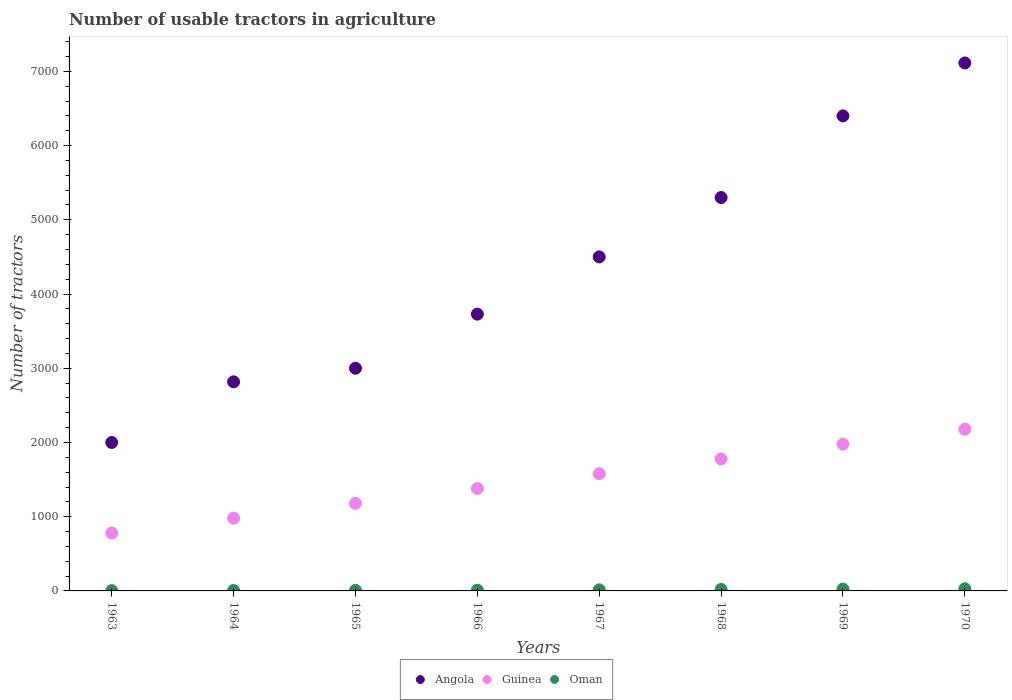How many different coloured dotlines are there?
Give a very brief answer. 3. Across all years, what is the maximum number of usable tractors in agriculture in Guinea?
Offer a very short reply. 2178. In which year was the number of usable tractors in agriculture in Angola minimum?
Offer a very short reply. 1963. What is the total number of usable tractors in agriculture in Oman in the graph?
Provide a short and direct response. 118. What is the difference between the number of usable tractors in agriculture in Angola in 1965 and that in 1969?
Make the answer very short. -3400. What is the difference between the number of usable tractors in agriculture in Angola in 1968 and the number of usable tractors in agriculture in Oman in 1963?
Offer a terse response. 5296. What is the average number of usable tractors in agriculture in Angola per year?
Provide a short and direct response. 4357.38. In the year 1967, what is the difference between the number of usable tractors in agriculture in Oman and number of usable tractors in agriculture in Guinea?
Your answer should be compact. -1564. What is the ratio of the number of usable tractors in agriculture in Angola in 1964 to that in 1969?
Give a very brief answer. 0.44. Is the number of usable tractors in agriculture in Oman in 1963 less than that in 1970?
Provide a short and direct response. Yes. What is the difference between the highest and the lowest number of usable tractors in agriculture in Angola?
Provide a succinct answer. 5113. In how many years, is the number of usable tractors in agriculture in Guinea greater than the average number of usable tractors in agriculture in Guinea taken over all years?
Offer a very short reply. 4. Is the sum of the number of usable tractors in agriculture in Guinea in 1964 and 1965 greater than the maximum number of usable tractors in agriculture in Oman across all years?
Your answer should be compact. Yes. Does the number of usable tractors in agriculture in Angola monotonically increase over the years?
Keep it short and to the point. Yes. Is the number of usable tractors in agriculture in Angola strictly greater than the number of usable tractors in agriculture in Oman over the years?
Ensure brevity in your answer.  Yes. Is the number of usable tractors in agriculture in Guinea strictly less than the number of usable tractors in agriculture in Angola over the years?
Your response must be concise. Yes. How many years are there in the graph?
Your answer should be very brief. 8. What is the difference between two consecutive major ticks on the Y-axis?
Your answer should be very brief. 1000. Does the graph contain any zero values?
Your answer should be very brief. No. Where does the legend appear in the graph?
Your answer should be very brief. Bottom center. How are the legend labels stacked?
Keep it short and to the point. Horizontal. What is the title of the graph?
Make the answer very short. Number of usable tractors in agriculture. What is the label or title of the Y-axis?
Ensure brevity in your answer.  Number of tractors. What is the Number of tractors of Angola in 1963?
Your answer should be compact. 2000. What is the Number of tractors of Guinea in 1963?
Make the answer very short. 780. What is the Number of tractors in Angola in 1964?
Your answer should be compact. 2817. What is the Number of tractors of Guinea in 1964?
Make the answer very short. 980. What is the Number of tractors in Angola in 1965?
Provide a short and direct response. 3000. What is the Number of tractors in Guinea in 1965?
Your answer should be very brief. 1180. What is the Number of tractors in Angola in 1966?
Your response must be concise. 3729. What is the Number of tractors of Guinea in 1966?
Your response must be concise. 1379. What is the Number of tractors of Angola in 1967?
Make the answer very short. 4500. What is the Number of tractors of Guinea in 1967?
Your answer should be very brief. 1579. What is the Number of tractors in Angola in 1968?
Your answer should be very brief. 5300. What is the Number of tractors in Guinea in 1968?
Offer a very short reply. 1778. What is the Number of tractors in Angola in 1969?
Make the answer very short. 6400. What is the Number of tractors of Guinea in 1969?
Give a very brief answer. 1978. What is the Number of tractors in Oman in 1969?
Offer a very short reply. 25. What is the Number of tractors of Angola in 1970?
Keep it short and to the point. 7113. What is the Number of tractors of Guinea in 1970?
Keep it short and to the point. 2178. Across all years, what is the maximum Number of tractors in Angola?
Provide a short and direct response. 7113. Across all years, what is the maximum Number of tractors in Guinea?
Offer a terse response. 2178. Across all years, what is the maximum Number of tractors of Oman?
Keep it short and to the point. 30. Across all years, what is the minimum Number of tractors in Angola?
Provide a short and direct response. 2000. Across all years, what is the minimum Number of tractors in Guinea?
Your answer should be very brief. 780. Across all years, what is the minimum Number of tractors of Oman?
Ensure brevity in your answer.  4. What is the total Number of tractors in Angola in the graph?
Make the answer very short. 3.49e+04. What is the total Number of tractors in Guinea in the graph?
Your response must be concise. 1.18e+04. What is the total Number of tractors in Oman in the graph?
Make the answer very short. 118. What is the difference between the Number of tractors in Angola in 1963 and that in 1964?
Make the answer very short. -817. What is the difference between the Number of tractors of Guinea in 1963 and that in 1964?
Ensure brevity in your answer.  -200. What is the difference between the Number of tractors of Oman in 1963 and that in 1964?
Provide a succinct answer. -2. What is the difference between the Number of tractors in Angola in 1963 and that in 1965?
Keep it short and to the point. -1000. What is the difference between the Number of tractors in Guinea in 1963 and that in 1965?
Your answer should be very brief. -400. What is the difference between the Number of tractors of Oman in 1963 and that in 1965?
Offer a terse response. -4. What is the difference between the Number of tractors in Angola in 1963 and that in 1966?
Your answer should be very brief. -1729. What is the difference between the Number of tractors of Guinea in 1963 and that in 1966?
Make the answer very short. -599. What is the difference between the Number of tractors in Angola in 1963 and that in 1967?
Provide a short and direct response. -2500. What is the difference between the Number of tractors in Guinea in 1963 and that in 1967?
Offer a very short reply. -799. What is the difference between the Number of tractors in Oman in 1963 and that in 1967?
Provide a short and direct response. -11. What is the difference between the Number of tractors of Angola in 1963 and that in 1968?
Your response must be concise. -3300. What is the difference between the Number of tractors of Guinea in 1963 and that in 1968?
Your answer should be very brief. -998. What is the difference between the Number of tractors in Angola in 1963 and that in 1969?
Ensure brevity in your answer.  -4400. What is the difference between the Number of tractors in Guinea in 1963 and that in 1969?
Make the answer very short. -1198. What is the difference between the Number of tractors of Angola in 1963 and that in 1970?
Give a very brief answer. -5113. What is the difference between the Number of tractors in Guinea in 1963 and that in 1970?
Provide a short and direct response. -1398. What is the difference between the Number of tractors in Angola in 1964 and that in 1965?
Your answer should be compact. -183. What is the difference between the Number of tractors in Guinea in 1964 and that in 1965?
Keep it short and to the point. -200. What is the difference between the Number of tractors in Oman in 1964 and that in 1965?
Ensure brevity in your answer.  -2. What is the difference between the Number of tractors of Angola in 1964 and that in 1966?
Provide a short and direct response. -912. What is the difference between the Number of tractors in Guinea in 1964 and that in 1966?
Your answer should be very brief. -399. What is the difference between the Number of tractors of Oman in 1964 and that in 1966?
Your answer should be compact. -4. What is the difference between the Number of tractors in Angola in 1964 and that in 1967?
Your answer should be very brief. -1683. What is the difference between the Number of tractors of Guinea in 1964 and that in 1967?
Keep it short and to the point. -599. What is the difference between the Number of tractors of Angola in 1964 and that in 1968?
Offer a terse response. -2483. What is the difference between the Number of tractors of Guinea in 1964 and that in 1968?
Your response must be concise. -798. What is the difference between the Number of tractors of Angola in 1964 and that in 1969?
Your answer should be very brief. -3583. What is the difference between the Number of tractors of Guinea in 1964 and that in 1969?
Your answer should be very brief. -998. What is the difference between the Number of tractors of Oman in 1964 and that in 1969?
Give a very brief answer. -19. What is the difference between the Number of tractors of Angola in 1964 and that in 1970?
Keep it short and to the point. -4296. What is the difference between the Number of tractors in Guinea in 1964 and that in 1970?
Your answer should be very brief. -1198. What is the difference between the Number of tractors in Oman in 1964 and that in 1970?
Keep it short and to the point. -24. What is the difference between the Number of tractors in Angola in 1965 and that in 1966?
Offer a terse response. -729. What is the difference between the Number of tractors of Guinea in 1965 and that in 1966?
Provide a short and direct response. -199. What is the difference between the Number of tractors of Oman in 1965 and that in 1966?
Ensure brevity in your answer.  -2. What is the difference between the Number of tractors in Angola in 1965 and that in 1967?
Provide a short and direct response. -1500. What is the difference between the Number of tractors in Guinea in 1965 and that in 1967?
Provide a short and direct response. -399. What is the difference between the Number of tractors in Angola in 1965 and that in 1968?
Provide a short and direct response. -2300. What is the difference between the Number of tractors in Guinea in 1965 and that in 1968?
Your answer should be very brief. -598. What is the difference between the Number of tractors in Angola in 1965 and that in 1969?
Keep it short and to the point. -3400. What is the difference between the Number of tractors of Guinea in 1965 and that in 1969?
Ensure brevity in your answer.  -798. What is the difference between the Number of tractors in Oman in 1965 and that in 1969?
Give a very brief answer. -17. What is the difference between the Number of tractors in Angola in 1965 and that in 1970?
Provide a short and direct response. -4113. What is the difference between the Number of tractors in Guinea in 1965 and that in 1970?
Give a very brief answer. -998. What is the difference between the Number of tractors in Oman in 1965 and that in 1970?
Ensure brevity in your answer.  -22. What is the difference between the Number of tractors of Angola in 1966 and that in 1967?
Provide a short and direct response. -771. What is the difference between the Number of tractors of Guinea in 1966 and that in 1967?
Your answer should be very brief. -200. What is the difference between the Number of tractors of Angola in 1966 and that in 1968?
Offer a terse response. -1571. What is the difference between the Number of tractors in Guinea in 1966 and that in 1968?
Ensure brevity in your answer.  -399. What is the difference between the Number of tractors of Oman in 1966 and that in 1968?
Your response must be concise. -10. What is the difference between the Number of tractors in Angola in 1966 and that in 1969?
Keep it short and to the point. -2671. What is the difference between the Number of tractors in Guinea in 1966 and that in 1969?
Your answer should be very brief. -599. What is the difference between the Number of tractors in Angola in 1966 and that in 1970?
Provide a short and direct response. -3384. What is the difference between the Number of tractors in Guinea in 1966 and that in 1970?
Provide a short and direct response. -799. What is the difference between the Number of tractors of Angola in 1967 and that in 1968?
Give a very brief answer. -800. What is the difference between the Number of tractors of Guinea in 1967 and that in 1968?
Your response must be concise. -199. What is the difference between the Number of tractors of Angola in 1967 and that in 1969?
Keep it short and to the point. -1900. What is the difference between the Number of tractors in Guinea in 1967 and that in 1969?
Give a very brief answer. -399. What is the difference between the Number of tractors of Oman in 1967 and that in 1969?
Your answer should be compact. -10. What is the difference between the Number of tractors of Angola in 1967 and that in 1970?
Make the answer very short. -2613. What is the difference between the Number of tractors in Guinea in 1967 and that in 1970?
Provide a succinct answer. -599. What is the difference between the Number of tractors of Oman in 1967 and that in 1970?
Provide a short and direct response. -15. What is the difference between the Number of tractors of Angola in 1968 and that in 1969?
Your response must be concise. -1100. What is the difference between the Number of tractors of Guinea in 1968 and that in 1969?
Offer a very short reply. -200. What is the difference between the Number of tractors in Angola in 1968 and that in 1970?
Keep it short and to the point. -1813. What is the difference between the Number of tractors in Guinea in 1968 and that in 1970?
Make the answer very short. -400. What is the difference between the Number of tractors in Angola in 1969 and that in 1970?
Make the answer very short. -713. What is the difference between the Number of tractors of Guinea in 1969 and that in 1970?
Give a very brief answer. -200. What is the difference between the Number of tractors of Angola in 1963 and the Number of tractors of Guinea in 1964?
Provide a short and direct response. 1020. What is the difference between the Number of tractors in Angola in 1963 and the Number of tractors in Oman in 1964?
Ensure brevity in your answer.  1994. What is the difference between the Number of tractors of Guinea in 1963 and the Number of tractors of Oman in 1964?
Offer a very short reply. 774. What is the difference between the Number of tractors in Angola in 1963 and the Number of tractors in Guinea in 1965?
Your answer should be compact. 820. What is the difference between the Number of tractors of Angola in 1963 and the Number of tractors of Oman in 1965?
Your answer should be compact. 1992. What is the difference between the Number of tractors of Guinea in 1963 and the Number of tractors of Oman in 1965?
Your answer should be very brief. 772. What is the difference between the Number of tractors of Angola in 1963 and the Number of tractors of Guinea in 1966?
Give a very brief answer. 621. What is the difference between the Number of tractors of Angola in 1963 and the Number of tractors of Oman in 1966?
Keep it short and to the point. 1990. What is the difference between the Number of tractors in Guinea in 1963 and the Number of tractors in Oman in 1966?
Offer a very short reply. 770. What is the difference between the Number of tractors in Angola in 1963 and the Number of tractors in Guinea in 1967?
Give a very brief answer. 421. What is the difference between the Number of tractors in Angola in 1963 and the Number of tractors in Oman in 1967?
Offer a very short reply. 1985. What is the difference between the Number of tractors of Guinea in 1963 and the Number of tractors of Oman in 1967?
Make the answer very short. 765. What is the difference between the Number of tractors of Angola in 1963 and the Number of tractors of Guinea in 1968?
Your answer should be compact. 222. What is the difference between the Number of tractors of Angola in 1963 and the Number of tractors of Oman in 1968?
Provide a succinct answer. 1980. What is the difference between the Number of tractors in Guinea in 1963 and the Number of tractors in Oman in 1968?
Offer a terse response. 760. What is the difference between the Number of tractors of Angola in 1963 and the Number of tractors of Guinea in 1969?
Offer a terse response. 22. What is the difference between the Number of tractors in Angola in 1963 and the Number of tractors in Oman in 1969?
Make the answer very short. 1975. What is the difference between the Number of tractors in Guinea in 1963 and the Number of tractors in Oman in 1969?
Give a very brief answer. 755. What is the difference between the Number of tractors of Angola in 1963 and the Number of tractors of Guinea in 1970?
Your response must be concise. -178. What is the difference between the Number of tractors in Angola in 1963 and the Number of tractors in Oman in 1970?
Offer a terse response. 1970. What is the difference between the Number of tractors in Guinea in 1963 and the Number of tractors in Oman in 1970?
Your answer should be very brief. 750. What is the difference between the Number of tractors in Angola in 1964 and the Number of tractors in Guinea in 1965?
Your answer should be very brief. 1637. What is the difference between the Number of tractors of Angola in 1964 and the Number of tractors of Oman in 1965?
Provide a short and direct response. 2809. What is the difference between the Number of tractors of Guinea in 1964 and the Number of tractors of Oman in 1965?
Offer a very short reply. 972. What is the difference between the Number of tractors of Angola in 1964 and the Number of tractors of Guinea in 1966?
Keep it short and to the point. 1438. What is the difference between the Number of tractors of Angola in 1964 and the Number of tractors of Oman in 1966?
Offer a terse response. 2807. What is the difference between the Number of tractors of Guinea in 1964 and the Number of tractors of Oman in 1966?
Provide a succinct answer. 970. What is the difference between the Number of tractors of Angola in 1964 and the Number of tractors of Guinea in 1967?
Your answer should be compact. 1238. What is the difference between the Number of tractors of Angola in 1964 and the Number of tractors of Oman in 1967?
Your answer should be very brief. 2802. What is the difference between the Number of tractors of Guinea in 1964 and the Number of tractors of Oman in 1967?
Make the answer very short. 965. What is the difference between the Number of tractors of Angola in 1964 and the Number of tractors of Guinea in 1968?
Give a very brief answer. 1039. What is the difference between the Number of tractors of Angola in 1964 and the Number of tractors of Oman in 1968?
Give a very brief answer. 2797. What is the difference between the Number of tractors of Guinea in 1964 and the Number of tractors of Oman in 1968?
Offer a very short reply. 960. What is the difference between the Number of tractors in Angola in 1964 and the Number of tractors in Guinea in 1969?
Offer a terse response. 839. What is the difference between the Number of tractors in Angola in 1964 and the Number of tractors in Oman in 1969?
Your answer should be very brief. 2792. What is the difference between the Number of tractors of Guinea in 1964 and the Number of tractors of Oman in 1969?
Give a very brief answer. 955. What is the difference between the Number of tractors in Angola in 1964 and the Number of tractors in Guinea in 1970?
Provide a short and direct response. 639. What is the difference between the Number of tractors of Angola in 1964 and the Number of tractors of Oman in 1970?
Your answer should be compact. 2787. What is the difference between the Number of tractors of Guinea in 1964 and the Number of tractors of Oman in 1970?
Provide a short and direct response. 950. What is the difference between the Number of tractors of Angola in 1965 and the Number of tractors of Guinea in 1966?
Your answer should be very brief. 1621. What is the difference between the Number of tractors of Angola in 1965 and the Number of tractors of Oman in 1966?
Provide a short and direct response. 2990. What is the difference between the Number of tractors in Guinea in 1965 and the Number of tractors in Oman in 1966?
Offer a very short reply. 1170. What is the difference between the Number of tractors in Angola in 1965 and the Number of tractors in Guinea in 1967?
Offer a very short reply. 1421. What is the difference between the Number of tractors in Angola in 1965 and the Number of tractors in Oman in 1967?
Make the answer very short. 2985. What is the difference between the Number of tractors of Guinea in 1965 and the Number of tractors of Oman in 1967?
Your response must be concise. 1165. What is the difference between the Number of tractors of Angola in 1965 and the Number of tractors of Guinea in 1968?
Give a very brief answer. 1222. What is the difference between the Number of tractors in Angola in 1965 and the Number of tractors in Oman in 1968?
Give a very brief answer. 2980. What is the difference between the Number of tractors of Guinea in 1965 and the Number of tractors of Oman in 1968?
Offer a terse response. 1160. What is the difference between the Number of tractors of Angola in 1965 and the Number of tractors of Guinea in 1969?
Your answer should be compact. 1022. What is the difference between the Number of tractors in Angola in 1965 and the Number of tractors in Oman in 1969?
Keep it short and to the point. 2975. What is the difference between the Number of tractors of Guinea in 1965 and the Number of tractors of Oman in 1969?
Provide a short and direct response. 1155. What is the difference between the Number of tractors of Angola in 1965 and the Number of tractors of Guinea in 1970?
Provide a short and direct response. 822. What is the difference between the Number of tractors of Angola in 1965 and the Number of tractors of Oman in 1970?
Make the answer very short. 2970. What is the difference between the Number of tractors in Guinea in 1965 and the Number of tractors in Oman in 1970?
Your answer should be compact. 1150. What is the difference between the Number of tractors in Angola in 1966 and the Number of tractors in Guinea in 1967?
Offer a very short reply. 2150. What is the difference between the Number of tractors in Angola in 1966 and the Number of tractors in Oman in 1967?
Ensure brevity in your answer.  3714. What is the difference between the Number of tractors in Guinea in 1966 and the Number of tractors in Oman in 1967?
Your answer should be compact. 1364. What is the difference between the Number of tractors of Angola in 1966 and the Number of tractors of Guinea in 1968?
Make the answer very short. 1951. What is the difference between the Number of tractors in Angola in 1966 and the Number of tractors in Oman in 1968?
Give a very brief answer. 3709. What is the difference between the Number of tractors in Guinea in 1966 and the Number of tractors in Oman in 1968?
Give a very brief answer. 1359. What is the difference between the Number of tractors of Angola in 1966 and the Number of tractors of Guinea in 1969?
Your answer should be very brief. 1751. What is the difference between the Number of tractors in Angola in 1966 and the Number of tractors in Oman in 1969?
Make the answer very short. 3704. What is the difference between the Number of tractors in Guinea in 1966 and the Number of tractors in Oman in 1969?
Your answer should be compact. 1354. What is the difference between the Number of tractors of Angola in 1966 and the Number of tractors of Guinea in 1970?
Offer a terse response. 1551. What is the difference between the Number of tractors in Angola in 1966 and the Number of tractors in Oman in 1970?
Provide a succinct answer. 3699. What is the difference between the Number of tractors of Guinea in 1966 and the Number of tractors of Oman in 1970?
Keep it short and to the point. 1349. What is the difference between the Number of tractors of Angola in 1967 and the Number of tractors of Guinea in 1968?
Your answer should be very brief. 2722. What is the difference between the Number of tractors of Angola in 1967 and the Number of tractors of Oman in 1968?
Make the answer very short. 4480. What is the difference between the Number of tractors of Guinea in 1967 and the Number of tractors of Oman in 1968?
Make the answer very short. 1559. What is the difference between the Number of tractors of Angola in 1967 and the Number of tractors of Guinea in 1969?
Your response must be concise. 2522. What is the difference between the Number of tractors of Angola in 1967 and the Number of tractors of Oman in 1969?
Make the answer very short. 4475. What is the difference between the Number of tractors in Guinea in 1967 and the Number of tractors in Oman in 1969?
Your response must be concise. 1554. What is the difference between the Number of tractors in Angola in 1967 and the Number of tractors in Guinea in 1970?
Provide a succinct answer. 2322. What is the difference between the Number of tractors of Angola in 1967 and the Number of tractors of Oman in 1970?
Give a very brief answer. 4470. What is the difference between the Number of tractors in Guinea in 1967 and the Number of tractors in Oman in 1970?
Provide a short and direct response. 1549. What is the difference between the Number of tractors of Angola in 1968 and the Number of tractors of Guinea in 1969?
Offer a very short reply. 3322. What is the difference between the Number of tractors in Angola in 1968 and the Number of tractors in Oman in 1969?
Your answer should be compact. 5275. What is the difference between the Number of tractors in Guinea in 1968 and the Number of tractors in Oman in 1969?
Your response must be concise. 1753. What is the difference between the Number of tractors in Angola in 1968 and the Number of tractors in Guinea in 1970?
Give a very brief answer. 3122. What is the difference between the Number of tractors of Angola in 1968 and the Number of tractors of Oman in 1970?
Provide a succinct answer. 5270. What is the difference between the Number of tractors of Guinea in 1968 and the Number of tractors of Oman in 1970?
Your answer should be compact. 1748. What is the difference between the Number of tractors in Angola in 1969 and the Number of tractors in Guinea in 1970?
Your answer should be compact. 4222. What is the difference between the Number of tractors in Angola in 1969 and the Number of tractors in Oman in 1970?
Keep it short and to the point. 6370. What is the difference between the Number of tractors in Guinea in 1969 and the Number of tractors in Oman in 1970?
Provide a short and direct response. 1948. What is the average Number of tractors in Angola per year?
Keep it short and to the point. 4357.38. What is the average Number of tractors in Guinea per year?
Your answer should be compact. 1479. What is the average Number of tractors in Oman per year?
Keep it short and to the point. 14.75. In the year 1963, what is the difference between the Number of tractors of Angola and Number of tractors of Guinea?
Provide a short and direct response. 1220. In the year 1963, what is the difference between the Number of tractors of Angola and Number of tractors of Oman?
Make the answer very short. 1996. In the year 1963, what is the difference between the Number of tractors in Guinea and Number of tractors in Oman?
Keep it short and to the point. 776. In the year 1964, what is the difference between the Number of tractors of Angola and Number of tractors of Guinea?
Offer a terse response. 1837. In the year 1964, what is the difference between the Number of tractors of Angola and Number of tractors of Oman?
Keep it short and to the point. 2811. In the year 1964, what is the difference between the Number of tractors of Guinea and Number of tractors of Oman?
Make the answer very short. 974. In the year 1965, what is the difference between the Number of tractors of Angola and Number of tractors of Guinea?
Ensure brevity in your answer.  1820. In the year 1965, what is the difference between the Number of tractors of Angola and Number of tractors of Oman?
Ensure brevity in your answer.  2992. In the year 1965, what is the difference between the Number of tractors of Guinea and Number of tractors of Oman?
Give a very brief answer. 1172. In the year 1966, what is the difference between the Number of tractors of Angola and Number of tractors of Guinea?
Offer a very short reply. 2350. In the year 1966, what is the difference between the Number of tractors in Angola and Number of tractors in Oman?
Offer a terse response. 3719. In the year 1966, what is the difference between the Number of tractors of Guinea and Number of tractors of Oman?
Offer a very short reply. 1369. In the year 1967, what is the difference between the Number of tractors in Angola and Number of tractors in Guinea?
Provide a succinct answer. 2921. In the year 1967, what is the difference between the Number of tractors in Angola and Number of tractors in Oman?
Your answer should be very brief. 4485. In the year 1967, what is the difference between the Number of tractors in Guinea and Number of tractors in Oman?
Your answer should be compact. 1564. In the year 1968, what is the difference between the Number of tractors in Angola and Number of tractors in Guinea?
Your response must be concise. 3522. In the year 1968, what is the difference between the Number of tractors in Angola and Number of tractors in Oman?
Provide a succinct answer. 5280. In the year 1968, what is the difference between the Number of tractors in Guinea and Number of tractors in Oman?
Keep it short and to the point. 1758. In the year 1969, what is the difference between the Number of tractors in Angola and Number of tractors in Guinea?
Offer a very short reply. 4422. In the year 1969, what is the difference between the Number of tractors of Angola and Number of tractors of Oman?
Keep it short and to the point. 6375. In the year 1969, what is the difference between the Number of tractors in Guinea and Number of tractors in Oman?
Your answer should be compact. 1953. In the year 1970, what is the difference between the Number of tractors of Angola and Number of tractors of Guinea?
Offer a very short reply. 4935. In the year 1970, what is the difference between the Number of tractors of Angola and Number of tractors of Oman?
Offer a very short reply. 7083. In the year 1970, what is the difference between the Number of tractors in Guinea and Number of tractors in Oman?
Give a very brief answer. 2148. What is the ratio of the Number of tractors of Angola in 1963 to that in 1964?
Ensure brevity in your answer.  0.71. What is the ratio of the Number of tractors of Guinea in 1963 to that in 1964?
Your answer should be compact. 0.8. What is the ratio of the Number of tractors in Angola in 1963 to that in 1965?
Provide a short and direct response. 0.67. What is the ratio of the Number of tractors of Guinea in 1963 to that in 1965?
Your answer should be very brief. 0.66. What is the ratio of the Number of tractors of Oman in 1963 to that in 1965?
Your response must be concise. 0.5. What is the ratio of the Number of tractors in Angola in 1963 to that in 1966?
Your response must be concise. 0.54. What is the ratio of the Number of tractors in Guinea in 1963 to that in 1966?
Keep it short and to the point. 0.57. What is the ratio of the Number of tractors of Angola in 1963 to that in 1967?
Offer a terse response. 0.44. What is the ratio of the Number of tractors in Guinea in 1963 to that in 1967?
Make the answer very short. 0.49. What is the ratio of the Number of tractors of Oman in 1963 to that in 1967?
Provide a succinct answer. 0.27. What is the ratio of the Number of tractors in Angola in 1963 to that in 1968?
Your answer should be very brief. 0.38. What is the ratio of the Number of tractors in Guinea in 1963 to that in 1968?
Provide a short and direct response. 0.44. What is the ratio of the Number of tractors in Angola in 1963 to that in 1969?
Your response must be concise. 0.31. What is the ratio of the Number of tractors in Guinea in 1963 to that in 1969?
Give a very brief answer. 0.39. What is the ratio of the Number of tractors in Oman in 1963 to that in 1969?
Make the answer very short. 0.16. What is the ratio of the Number of tractors of Angola in 1963 to that in 1970?
Your answer should be very brief. 0.28. What is the ratio of the Number of tractors in Guinea in 1963 to that in 1970?
Give a very brief answer. 0.36. What is the ratio of the Number of tractors of Oman in 1963 to that in 1970?
Your answer should be very brief. 0.13. What is the ratio of the Number of tractors in Angola in 1964 to that in 1965?
Give a very brief answer. 0.94. What is the ratio of the Number of tractors of Guinea in 1964 to that in 1965?
Offer a terse response. 0.83. What is the ratio of the Number of tractors of Oman in 1964 to that in 1965?
Offer a terse response. 0.75. What is the ratio of the Number of tractors in Angola in 1964 to that in 1966?
Keep it short and to the point. 0.76. What is the ratio of the Number of tractors in Guinea in 1964 to that in 1966?
Ensure brevity in your answer.  0.71. What is the ratio of the Number of tractors of Angola in 1964 to that in 1967?
Provide a succinct answer. 0.63. What is the ratio of the Number of tractors in Guinea in 1964 to that in 1967?
Give a very brief answer. 0.62. What is the ratio of the Number of tractors of Angola in 1964 to that in 1968?
Your response must be concise. 0.53. What is the ratio of the Number of tractors of Guinea in 1964 to that in 1968?
Offer a terse response. 0.55. What is the ratio of the Number of tractors in Oman in 1964 to that in 1968?
Offer a terse response. 0.3. What is the ratio of the Number of tractors in Angola in 1964 to that in 1969?
Your response must be concise. 0.44. What is the ratio of the Number of tractors in Guinea in 1964 to that in 1969?
Offer a very short reply. 0.5. What is the ratio of the Number of tractors in Oman in 1964 to that in 1969?
Your answer should be compact. 0.24. What is the ratio of the Number of tractors of Angola in 1964 to that in 1970?
Your response must be concise. 0.4. What is the ratio of the Number of tractors in Guinea in 1964 to that in 1970?
Offer a very short reply. 0.45. What is the ratio of the Number of tractors of Oman in 1964 to that in 1970?
Offer a very short reply. 0.2. What is the ratio of the Number of tractors in Angola in 1965 to that in 1966?
Provide a short and direct response. 0.8. What is the ratio of the Number of tractors of Guinea in 1965 to that in 1966?
Provide a short and direct response. 0.86. What is the ratio of the Number of tractors of Oman in 1965 to that in 1966?
Provide a short and direct response. 0.8. What is the ratio of the Number of tractors of Guinea in 1965 to that in 1967?
Provide a short and direct response. 0.75. What is the ratio of the Number of tractors in Oman in 1965 to that in 1967?
Provide a short and direct response. 0.53. What is the ratio of the Number of tractors in Angola in 1965 to that in 1968?
Offer a very short reply. 0.57. What is the ratio of the Number of tractors in Guinea in 1965 to that in 1968?
Offer a very short reply. 0.66. What is the ratio of the Number of tractors of Oman in 1965 to that in 1968?
Your answer should be compact. 0.4. What is the ratio of the Number of tractors of Angola in 1965 to that in 1969?
Make the answer very short. 0.47. What is the ratio of the Number of tractors in Guinea in 1965 to that in 1969?
Offer a terse response. 0.6. What is the ratio of the Number of tractors of Oman in 1965 to that in 1969?
Your answer should be very brief. 0.32. What is the ratio of the Number of tractors of Angola in 1965 to that in 1970?
Your answer should be compact. 0.42. What is the ratio of the Number of tractors in Guinea in 1965 to that in 1970?
Your answer should be compact. 0.54. What is the ratio of the Number of tractors of Oman in 1965 to that in 1970?
Provide a succinct answer. 0.27. What is the ratio of the Number of tractors in Angola in 1966 to that in 1967?
Your answer should be very brief. 0.83. What is the ratio of the Number of tractors in Guinea in 1966 to that in 1967?
Ensure brevity in your answer.  0.87. What is the ratio of the Number of tractors of Angola in 1966 to that in 1968?
Your answer should be very brief. 0.7. What is the ratio of the Number of tractors in Guinea in 1966 to that in 1968?
Offer a very short reply. 0.78. What is the ratio of the Number of tractors of Oman in 1966 to that in 1968?
Ensure brevity in your answer.  0.5. What is the ratio of the Number of tractors in Angola in 1966 to that in 1969?
Ensure brevity in your answer.  0.58. What is the ratio of the Number of tractors in Guinea in 1966 to that in 1969?
Your response must be concise. 0.7. What is the ratio of the Number of tractors in Oman in 1966 to that in 1969?
Your answer should be compact. 0.4. What is the ratio of the Number of tractors in Angola in 1966 to that in 1970?
Provide a short and direct response. 0.52. What is the ratio of the Number of tractors in Guinea in 1966 to that in 1970?
Provide a short and direct response. 0.63. What is the ratio of the Number of tractors in Angola in 1967 to that in 1968?
Your response must be concise. 0.85. What is the ratio of the Number of tractors of Guinea in 1967 to that in 1968?
Your answer should be very brief. 0.89. What is the ratio of the Number of tractors in Oman in 1967 to that in 1968?
Your answer should be very brief. 0.75. What is the ratio of the Number of tractors of Angola in 1967 to that in 1969?
Keep it short and to the point. 0.7. What is the ratio of the Number of tractors of Guinea in 1967 to that in 1969?
Ensure brevity in your answer.  0.8. What is the ratio of the Number of tractors of Angola in 1967 to that in 1970?
Provide a succinct answer. 0.63. What is the ratio of the Number of tractors of Guinea in 1967 to that in 1970?
Offer a terse response. 0.72. What is the ratio of the Number of tractors in Angola in 1968 to that in 1969?
Offer a terse response. 0.83. What is the ratio of the Number of tractors of Guinea in 1968 to that in 1969?
Your answer should be compact. 0.9. What is the ratio of the Number of tractors of Oman in 1968 to that in 1969?
Keep it short and to the point. 0.8. What is the ratio of the Number of tractors of Angola in 1968 to that in 1970?
Keep it short and to the point. 0.75. What is the ratio of the Number of tractors in Guinea in 1968 to that in 1970?
Offer a very short reply. 0.82. What is the ratio of the Number of tractors in Angola in 1969 to that in 1970?
Keep it short and to the point. 0.9. What is the ratio of the Number of tractors of Guinea in 1969 to that in 1970?
Provide a succinct answer. 0.91. What is the ratio of the Number of tractors of Oman in 1969 to that in 1970?
Your response must be concise. 0.83. What is the difference between the highest and the second highest Number of tractors of Angola?
Make the answer very short. 713. What is the difference between the highest and the lowest Number of tractors of Angola?
Provide a short and direct response. 5113. What is the difference between the highest and the lowest Number of tractors of Guinea?
Keep it short and to the point. 1398. 